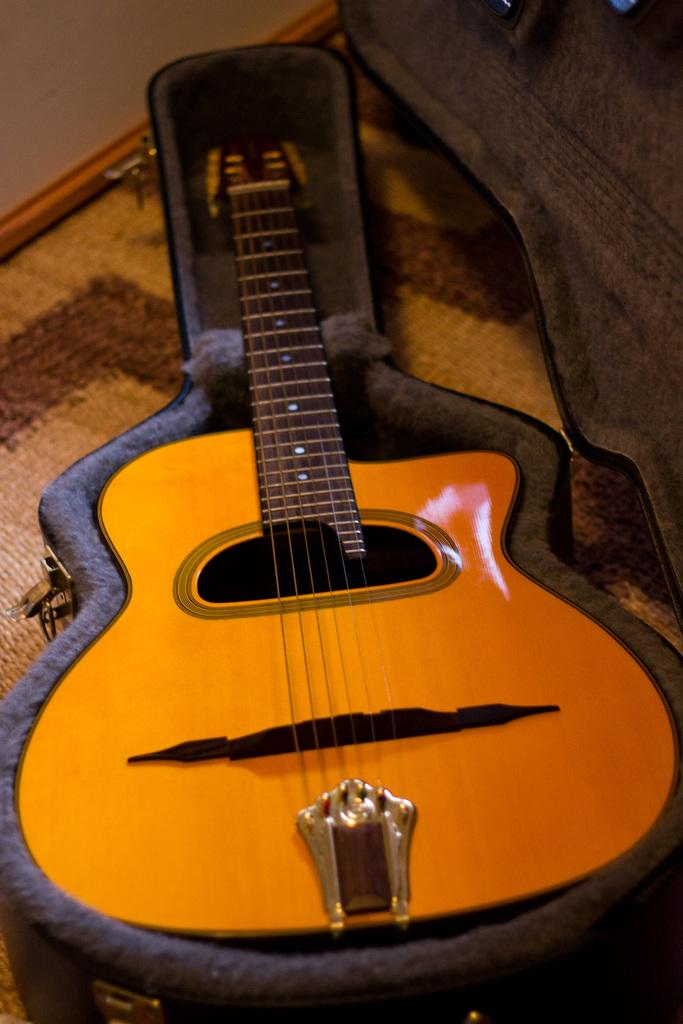What is covering the floor in the image? The floor is covered with a mat. What is placed on the mat? There is a guitar box on the mat. What is inside the guitar box? The guitar box contains a wooden guitar with strings. What can be seen behind the guitar in the image? There are items visible behind the guitar. What type of rake is leaning against the wall behind the guitar? There is no rake present in the image. What color is the skin of the dolls behind the guitar? There are no dolls present in the image. 